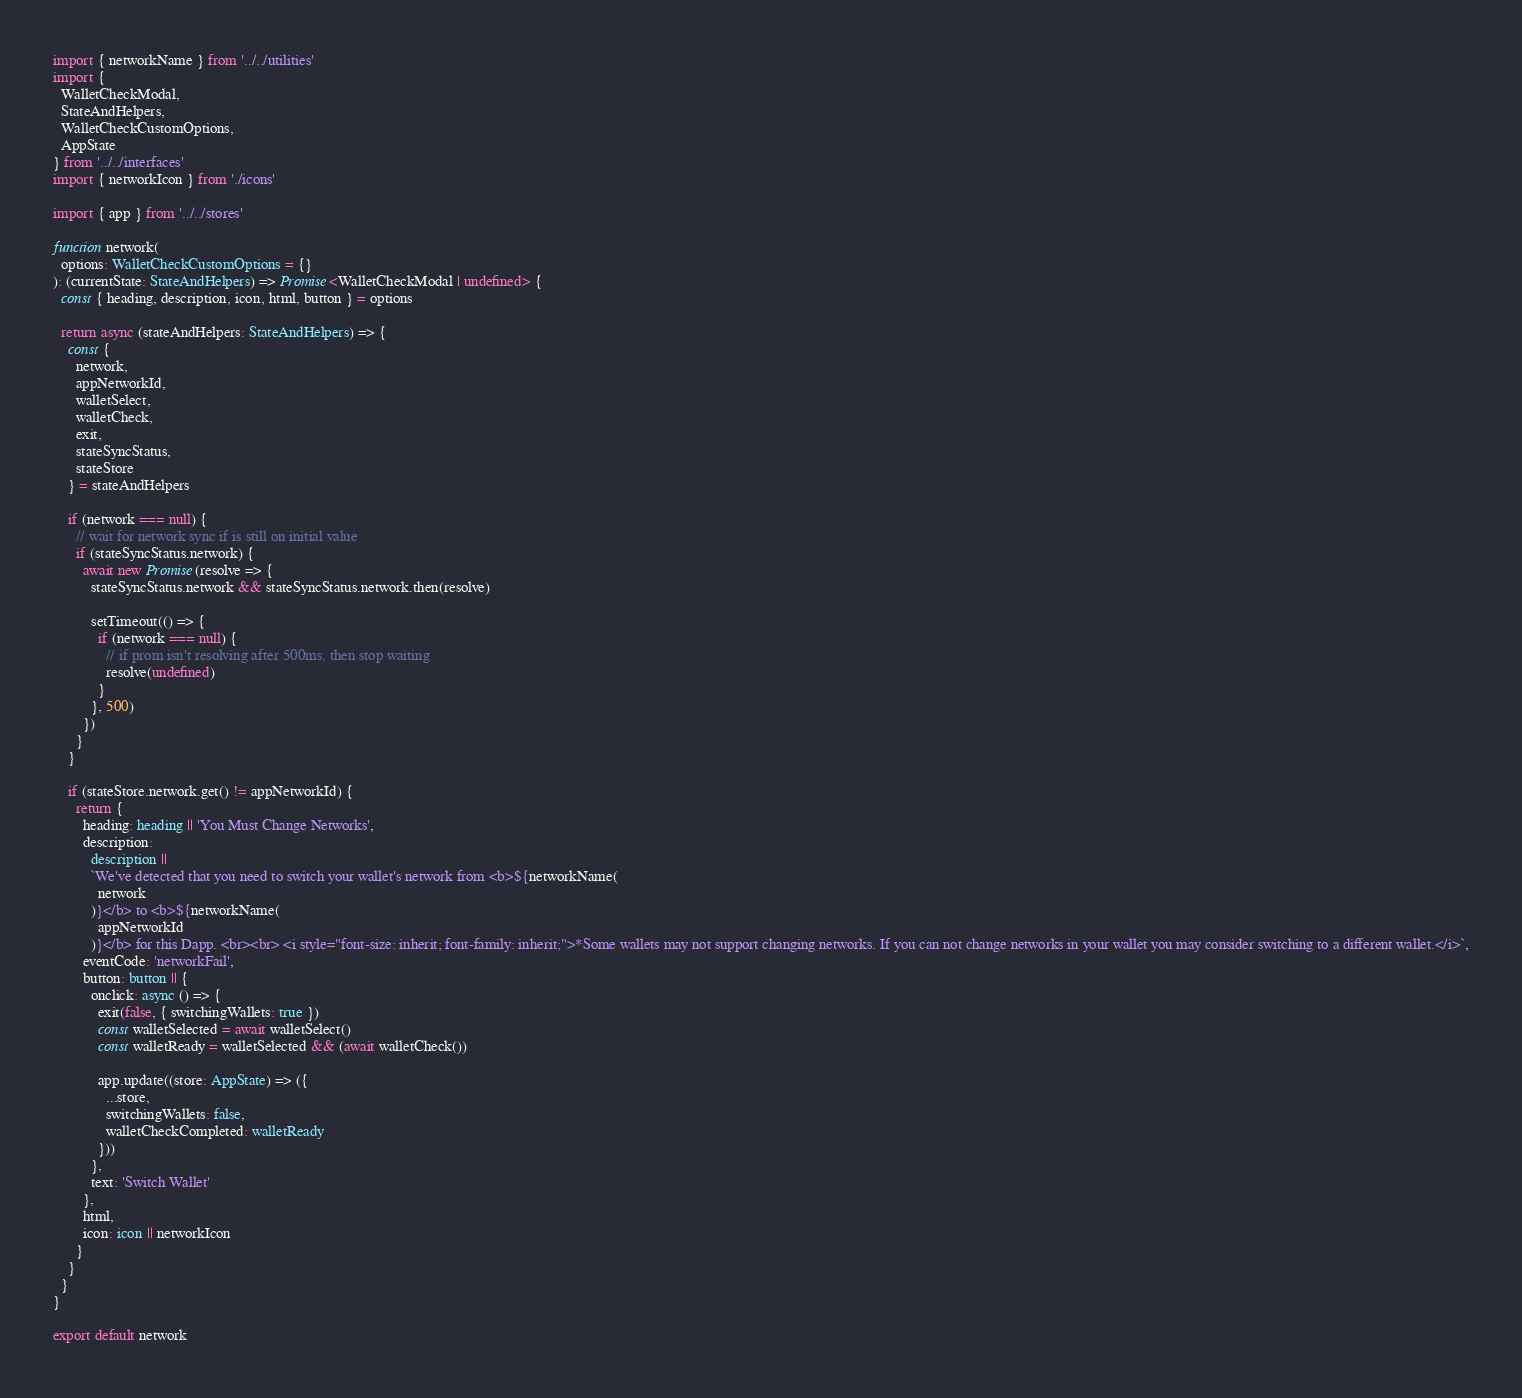<code> <loc_0><loc_0><loc_500><loc_500><_TypeScript_>import { networkName } from '../../utilities'
import {
  WalletCheckModal,
  StateAndHelpers,
  WalletCheckCustomOptions,
  AppState
} from '../../interfaces'
import { networkIcon } from './icons'

import { app } from '../../stores'

function network(
  options: WalletCheckCustomOptions = {}
): (currentState: StateAndHelpers) => Promise<WalletCheckModal | undefined> {
  const { heading, description, icon, html, button } = options

  return async (stateAndHelpers: StateAndHelpers) => {
    const {
      network,
      appNetworkId,
      walletSelect,
      walletCheck,
      exit,
      stateSyncStatus,
      stateStore
    } = stateAndHelpers

    if (network === null) {
      // wait for network sync if is still on initial value
      if (stateSyncStatus.network) {
        await new Promise(resolve => {
          stateSyncStatus.network && stateSyncStatus.network.then(resolve)

          setTimeout(() => {
            if (network === null) {
              // if prom isn't resolving after 500ms, then stop waiting
              resolve(undefined)
            }
          }, 500)
        })
      }
    }

    if (stateStore.network.get() != appNetworkId) {
      return {
        heading: heading || 'You Must Change Networks',
        description:
          description ||
          `We've detected that you need to switch your wallet's network from <b>${networkName(
            network
          )}</b> to <b>${networkName(
            appNetworkId
          )}</b> for this Dapp. <br><br> <i style="font-size: inherit; font-family: inherit;">*Some wallets may not support changing networks. If you can not change networks in your wallet you may consider switching to a different wallet.</i>`,
        eventCode: 'networkFail',
        button: button || {
          onclick: async () => {
            exit(false, { switchingWallets: true })
            const walletSelected = await walletSelect()
            const walletReady = walletSelected && (await walletCheck())

            app.update((store: AppState) => ({
              ...store,
              switchingWallets: false,
              walletCheckCompleted: walletReady
            }))
          },
          text: 'Switch Wallet'
        },
        html,
        icon: icon || networkIcon
      }
    }
  }
}

export default network
</code> 